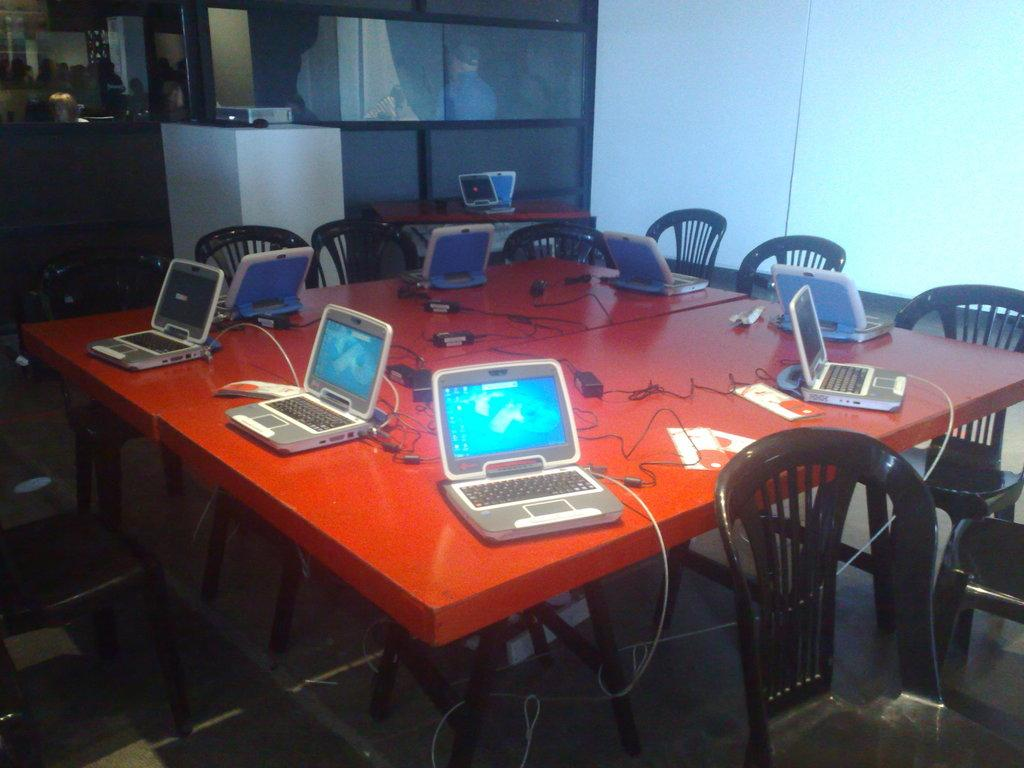What electronic devices are on the table in the image? There are laptops on a table in the image. What type of furniture is arranged around the table? There are chairs around the table in the image. What type of potato is being offered to the person sitting on the chair? There is no potato present in the image, and therefore no such offering can be observed. 